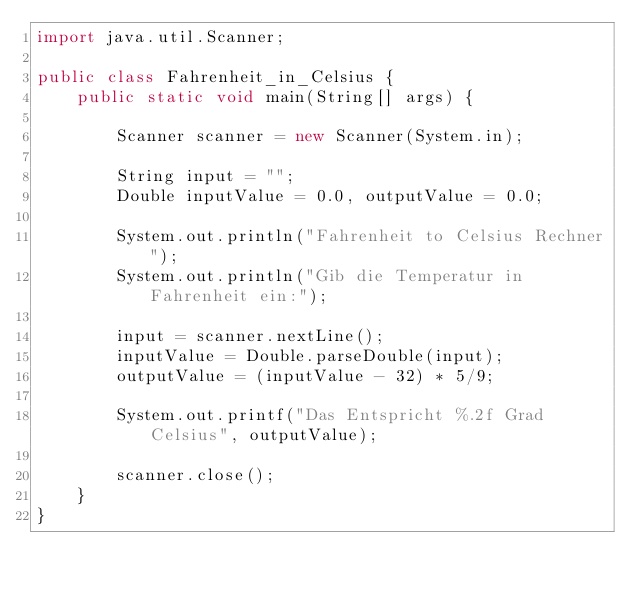Convert code to text. <code><loc_0><loc_0><loc_500><loc_500><_Java_>import java.util.Scanner;

public class Fahrenheit_in_Celsius {
    public static void main(String[] args) {

        Scanner scanner = new Scanner(System.in);

        String input = "";
        Double inputValue = 0.0, outputValue = 0.0;

        System.out.println("Fahrenheit to Celsius Rechner");
        System.out.println("Gib die Temperatur in Fahrenheit ein:");

        input = scanner.nextLine();
        inputValue = Double.parseDouble(input);
        outputValue = (inputValue - 32) * 5/9;

        System.out.printf("Das Entspricht %.2f Grad Celsius", outputValue);

        scanner.close();
    }
}
</code> 